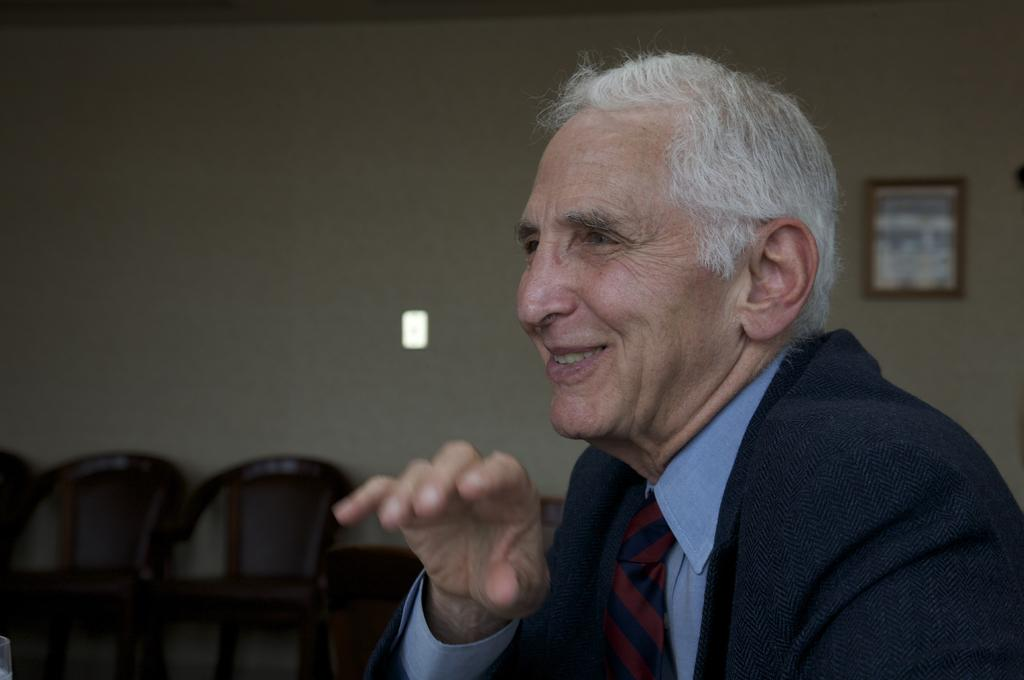Who is present in the image? There is a man in the image. What is the man's facial expression? The man is smiling. What is located behind the man? There is a wall behind the man. What type of furniture can be seen in the image? There are chairs in the image. What is hanging on the wall? There is a frame on the wall. What color are the cherries on the man's head in the image? There are no cherries present on the man's head in the image. What shape is the orange that the man is holding in the image? There is no orange present in the image. 